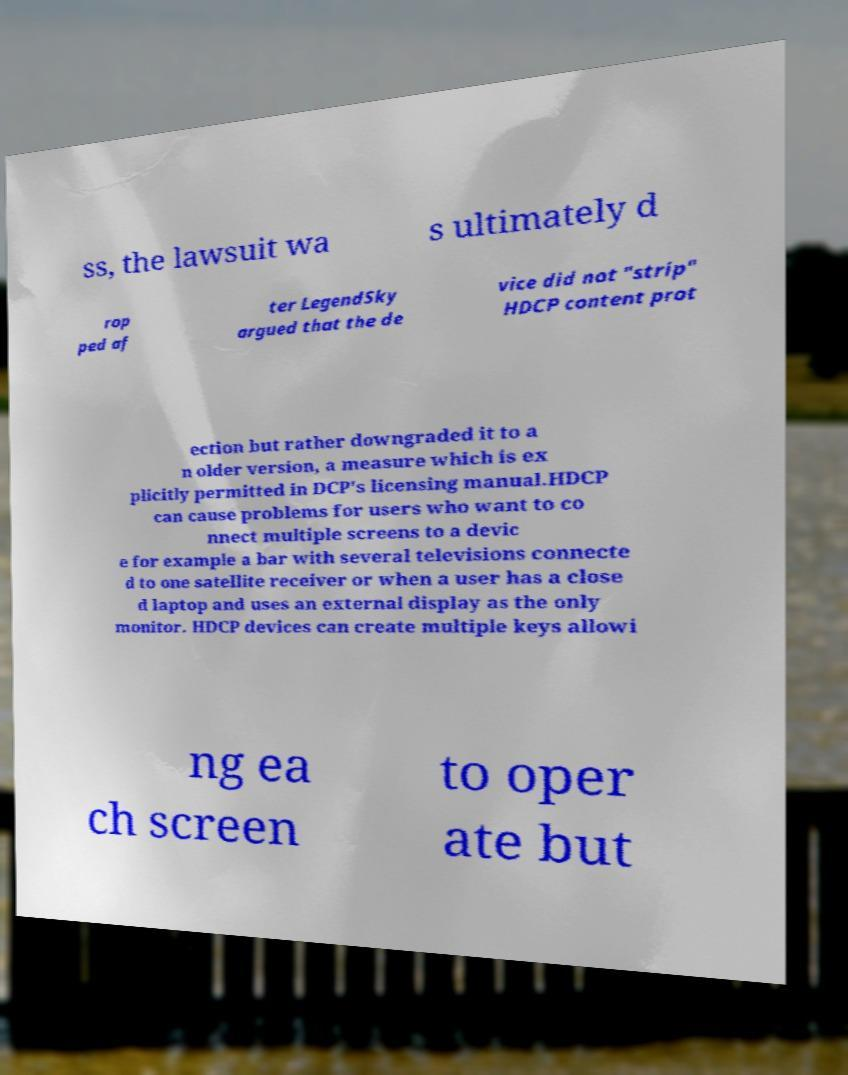Could you extract and type out the text from this image? ss, the lawsuit wa s ultimately d rop ped af ter LegendSky argued that the de vice did not "strip" HDCP content prot ection but rather downgraded it to a n older version, a measure which is ex plicitly permitted in DCP's licensing manual.HDCP can cause problems for users who want to co nnect multiple screens to a devic e for example a bar with several televisions connecte d to one satellite receiver or when a user has a close d laptop and uses an external display as the only monitor. HDCP devices can create multiple keys allowi ng ea ch screen to oper ate but 